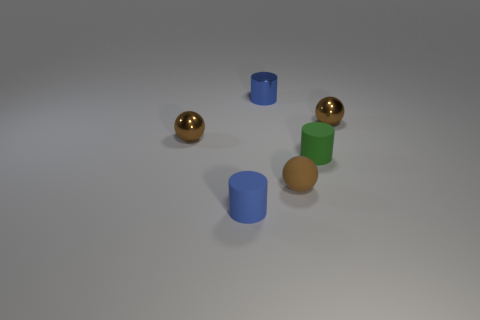What color is the metal sphere to the left of the cylinder behind the tiny cylinder right of the blue metal cylinder?
Ensure brevity in your answer.  Brown. What number of large things are cyan cubes or shiny objects?
Offer a terse response. 0. Are there an equal number of tiny blue matte cylinders that are on the right side of the blue matte thing and tiny green things?
Keep it short and to the point. No. There is a blue matte cylinder; are there any small green things on the left side of it?
Offer a terse response. No. How many shiny things are either gray cylinders or small spheres?
Give a very brief answer. 2. How many green matte things are behind the blue shiny object?
Offer a terse response. 0. Is there a red metallic object that has the same size as the metal cylinder?
Offer a very short reply. No. Are there any objects of the same color as the metallic cylinder?
Your answer should be compact. Yes. Is there any other thing that is the same size as the green rubber cylinder?
Ensure brevity in your answer.  Yes. What number of tiny things are the same color as the metallic cylinder?
Offer a very short reply. 1. 